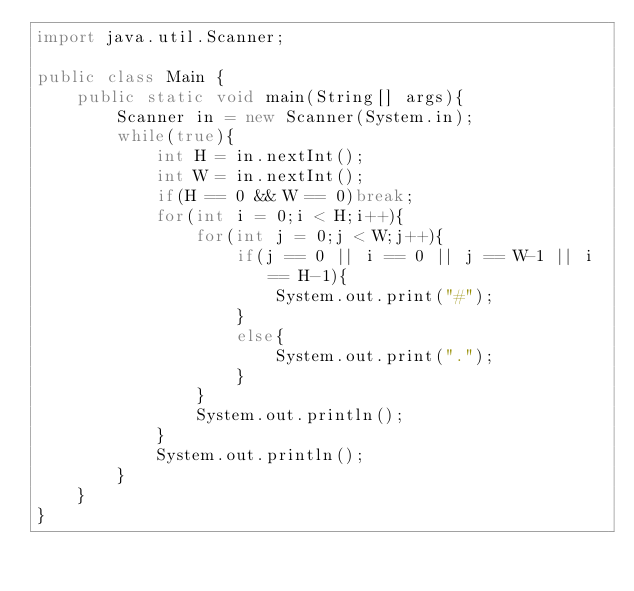Convert code to text. <code><loc_0><loc_0><loc_500><loc_500><_Java_>import java.util.Scanner;

public class Main {
	public static void main(String[] args){
		Scanner in = new Scanner(System.in);
		while(true){
			int H = in.nextInt();
			int W = in.nextInt();
			if(H == 0 && W == 0)break;
			for(int i = 0;i < H;i++){
				for(int j = 0;j < W;j++){
					if(j == 0 || i == 0 || j == W-1 || i == H-1){
						System.out.print("#");
					}
					else{
						System.out.print(".");
					}
				}
				System.out.println();
			}
			System.out.println();
		}
	}
}</code> 